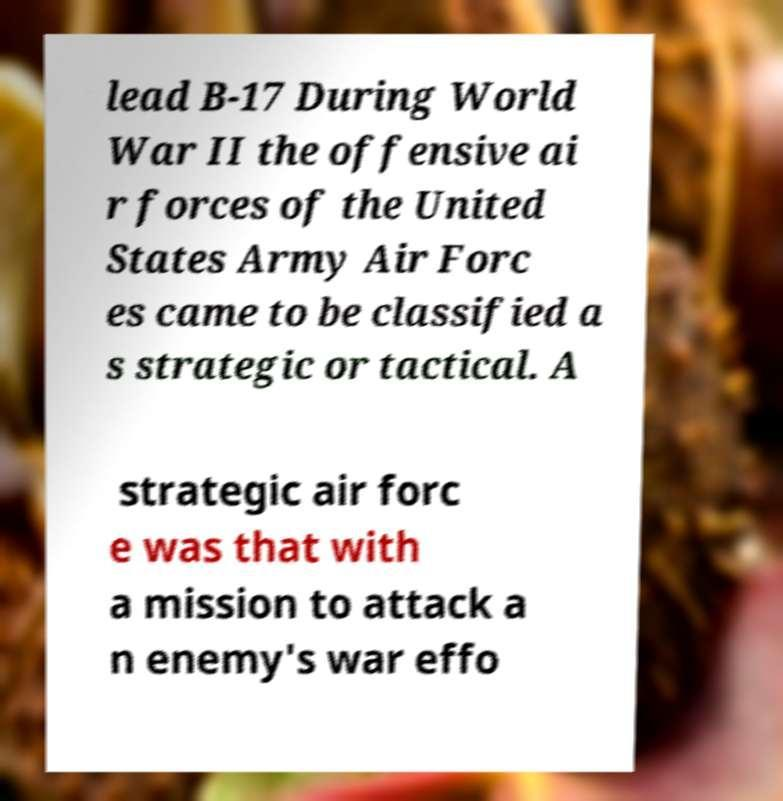Please read and relay the text visible in this image. What does it say? lead B-17 During World War II the offensive ai r forces of the United States Army Air Forc es came to be classified a s strategic or tactical. A strategic air forc e was that with a mission to attack a n enemy's war effo 